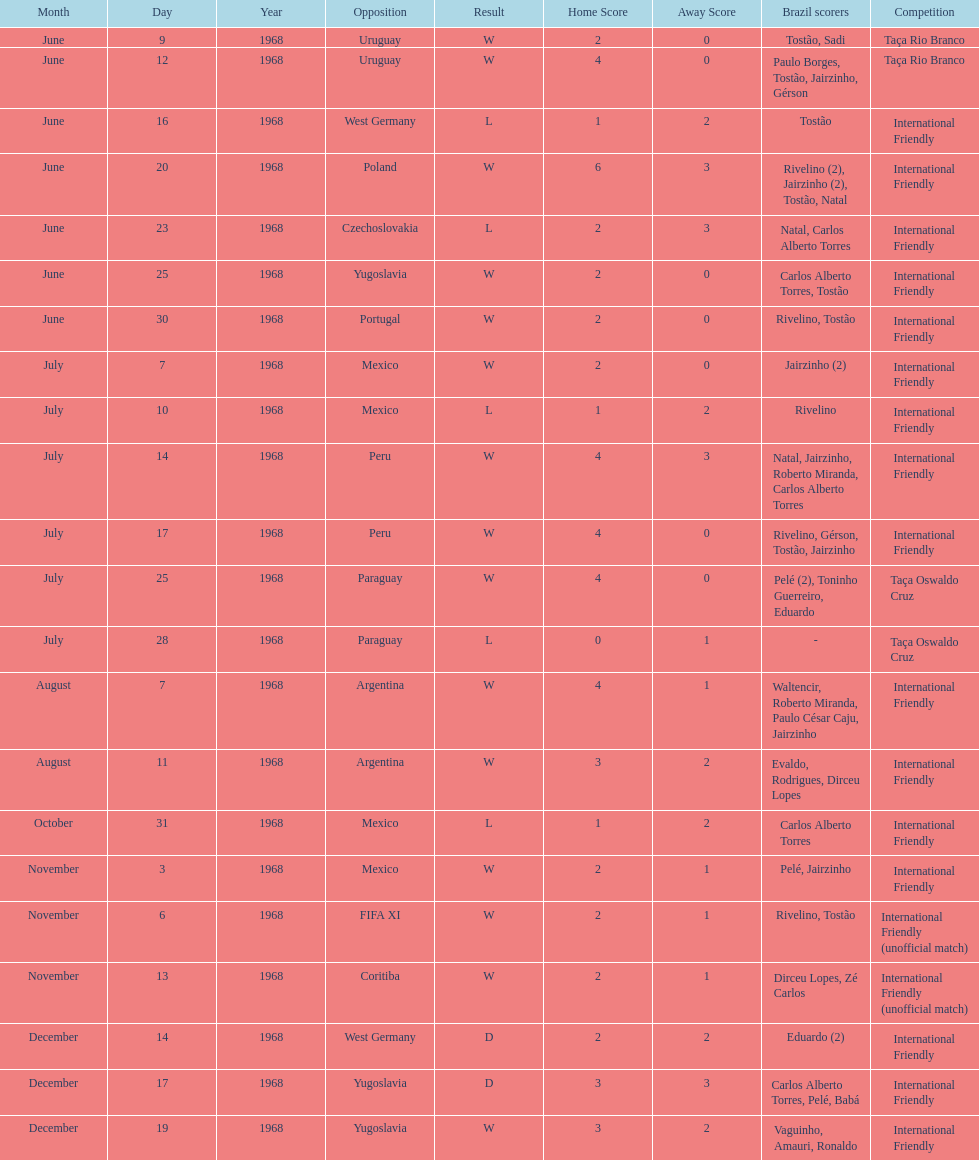Who played brazil previous to the game on june 30th? Yugoslavia. Write the full table. {'header': ['Month', 'Day', 'Year', 'Opposition', 'Result', 'Home Score', 'Away Score', 'Brazil scorers', 'Competition'], 'rows': [['June', '9', '1968', 'Uruguay', 'W', '2', '0', 'Tostão, Sadi', 'Taça Rio Branco'], ['June', '12', '1968', 'Uruguay', 'W', '4', '0', 'Paulo Borges, Tostão, Jairzinho, Gérson', 'Taça Rio Branco'], ['June', '16', '1968', 'West Germany', 'L', '1', '2', 'Tostão', 'International Friendly'], ['June', '20', '1968', 'Poland', 'W', '6', '3', 'Rivelino (2), Jairzinho (2), Tostão, Natal', 'International Friendly'], ['June', '23', '1968', 'Czechoslovakia', 'L', '2', '3', 'Natal, Carlos Alberto Torres', 'International Friendly'], ['June', '25', '1968', 'Yugoslavia', 'W', '2', '0', 'Carlos Alberto Torres, Tostão', 'International Friendly'], ['June', '30', '1968', 'Portugal', 'W', '2', '0', 'Rivelino, Tostão', 'International Friendly'], ['July', '7', '1968', 'Mexico', 'W', '2', '0', 'Jairzinho (2)', 'International Friendly'], ['July', '10', '1968', 'Mexico', 'L', '1', '2', 'Rivelino', 'International Friendly'], ['July', '14', '1968', 'Peru', 'W', '4', '3', 'Natal, Jairzinho, Roberto Miranda, Carlos Alberto Torres', 'International Friendly'], ['July', '17', '1968', 'Peru', 'W', '4', '0', 'Rivelino, Gérson, Tostão, Jairzinho', 'International Friendly'], ['July', '25', '1968', 'Paraguay', 'W', '4', '0', 'Pelé (2), Toninho Guerreiro, Eduardo', 'Taça Oswaldo Cruz'], ['July', '28', '1968', 'Paraguay', 'L', '0', '1', '-', 'Taça Oswaldo Cruz'], ['August', '7', '1968', 'Argentina', 'W', '4', '1', 'Waltencir, Roberto Miranda, Paulo César Caju, Jairzinho', 'International Friendly'], ['August', '11', '1968', 'Argentina', 'W', '3', '2', 'Evaldo, Rodrigues, Dirceu Lopes', 'International Friendly'], ['October', '31', '1968', 'Mexico', 'L', '1', '2', 'Carlos Alberto Torres', 'International Friendly'], ['November', '3', '1968', 'Mexico', 'W', '2', '1', 'Pelé, Jairzinho', 'International Friendly'], ['November', '6', '1968', 'FIFA XI', 'W', '2', '1', 'Rivelino, Tostão', 'International Friendly (unofficial match)'], ['November', '13', '1968', 'Coritiba', 'W', '2', '1', 'Dirceu Lopes, Zé Carlos', 'International Friendly (unofficial match)'], ['December', '14', '1968', 'West Germany', 'D', '2', '2', 'Eduardo (2)', 'International Friendly'], ['December', '17', '1968', 'Yugoslavia', 'D', '3', '3', 'Carlos Alberto Torres, Pelé, Babá', 'International Friendly'], ['December', '19', '1968', 'Yugoslavia', 'W', '3', '2', 'Vaguinho, Amauri, Ronaldo', 'International Friendly']]} 